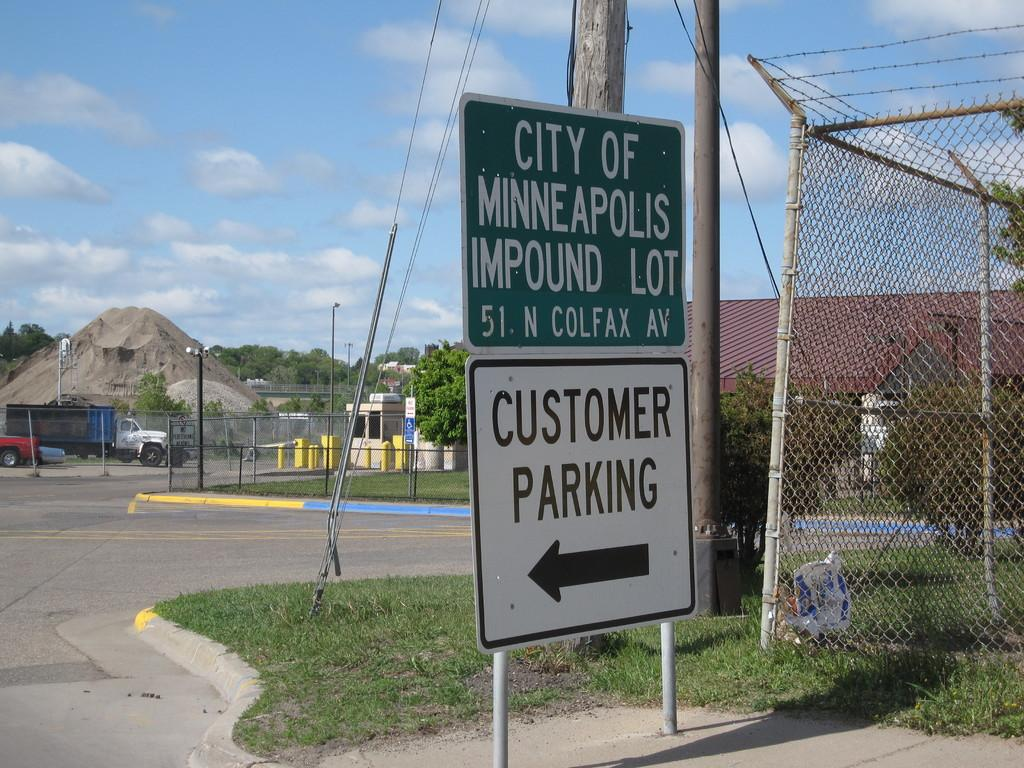<image>
Give a short and clear explanation of the subsequent image. Sign that says City of Minneapolis Impound Lot and Customer Parking. 